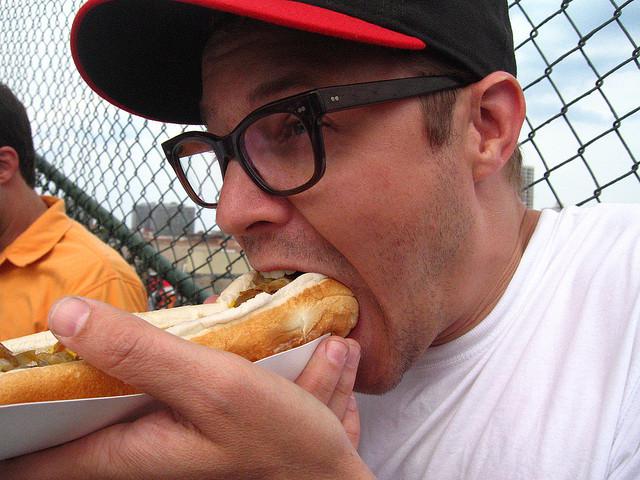Is he wearing glasses?
Answer briefly. Yes. What is the red object over the man's head?
Answer briefly. Hat. What is the size of this hot dog?
Keep it brief. Large. Can he finish it?
Short answer required. Yes. Is the man going to take a bite?
Quick response, please. Yes. 